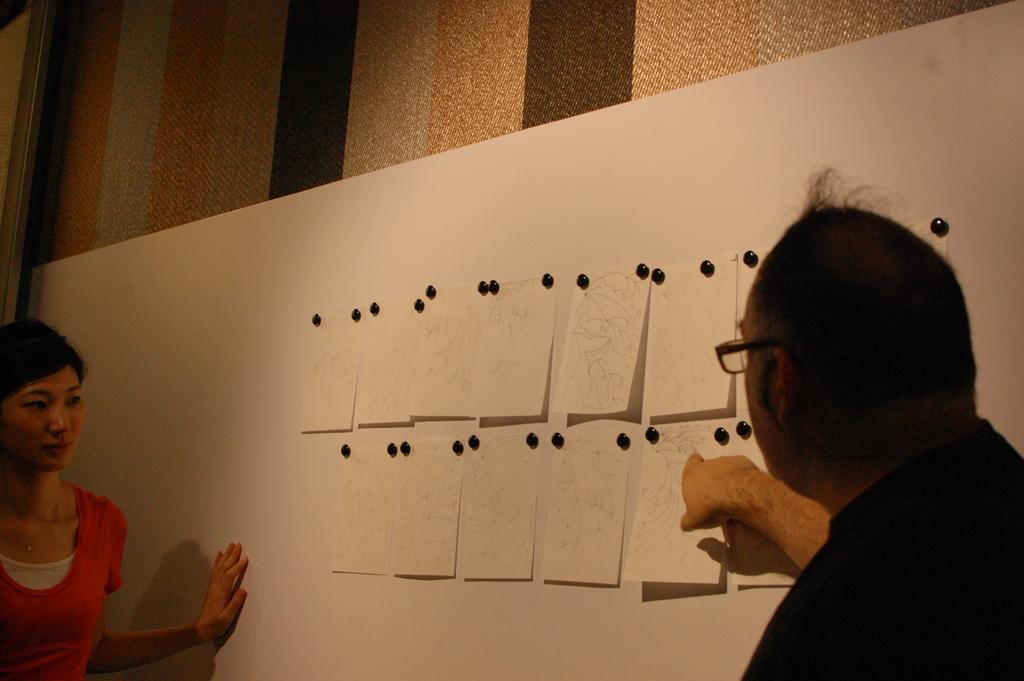Who are the people in the image? There is a boy and a girl in the image. What are the boy and girl doing in the image? The boy and girl are looking at papers in the image. How are the papers arranged in the image? The papers are attached to a board in the image. What can be seen in the background of the image? There is a wall in the background of the image. What type of food is the boy eating in the image? There is no food present in the image; the boy is looking at papers. 